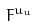Convert formula to latex. <formula><loc_0><loc_0><loc_500><loc_500>F ^ { u _ { u } }</formula> 